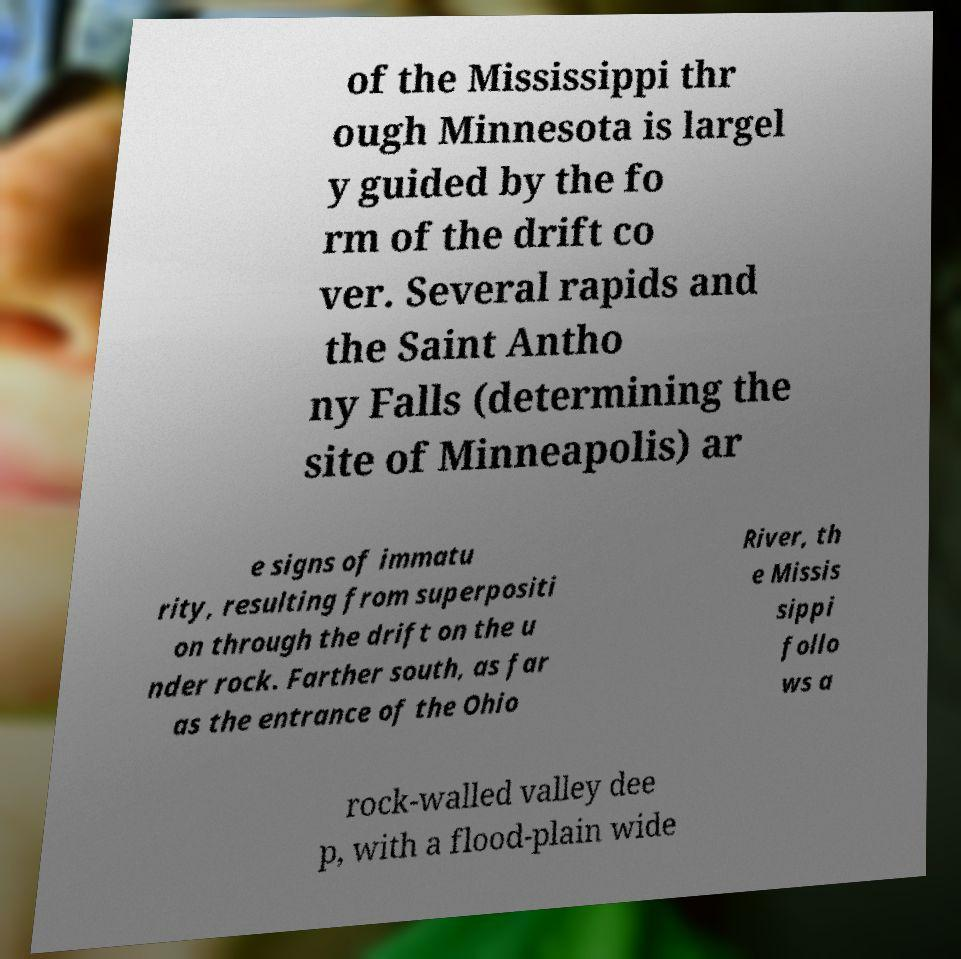Can you accurately transcribe the text from the provided image for me? of the Mississippi thr ough Minnesota is largel y guided by the fo rm of the drift co ver. Several rapids and the Saint Antho ny Falls (determining the site of Minneapolis) ar e signs of immatu rity, resulting from superpositi on through the drift on the u nder rock. Farther south, as far as the entrance of the Ohio River, th e Missis sippi follo ws a rock-walled valley dee p, with a flood-plain wide 